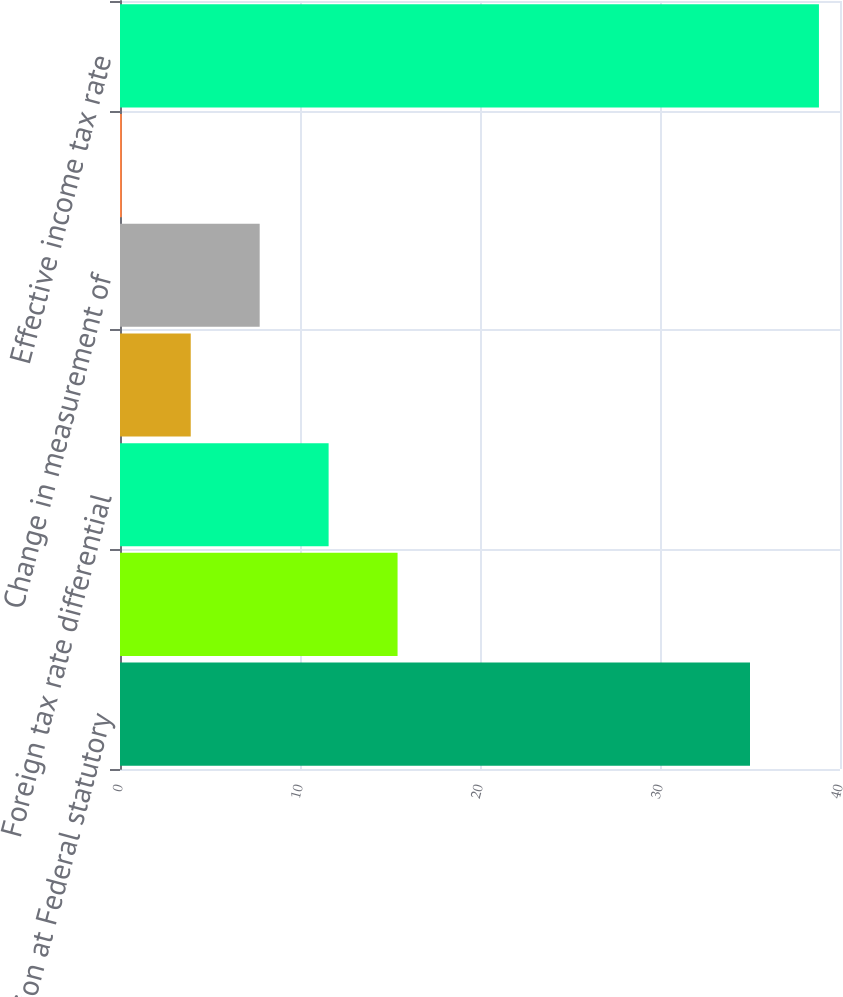Convert chart to OTSL. <chart><loc_0><loc_0><loc_500><loc_500><bar_chart><fcel>Provision at Federal statutory<fcel>State and local income taxes<fcel>Foreign tax rate differential<fcel>Nondeductible/nontaxable items<fcel>Change in measurement of<fcel>Other<fcel>Effective income tax rate<nl><fcel>35<fcel>15.42<fcel>11.59<fcel>3.93<fcel>7.76<fcel>0.1<fcel>38.83<nl></chart> 